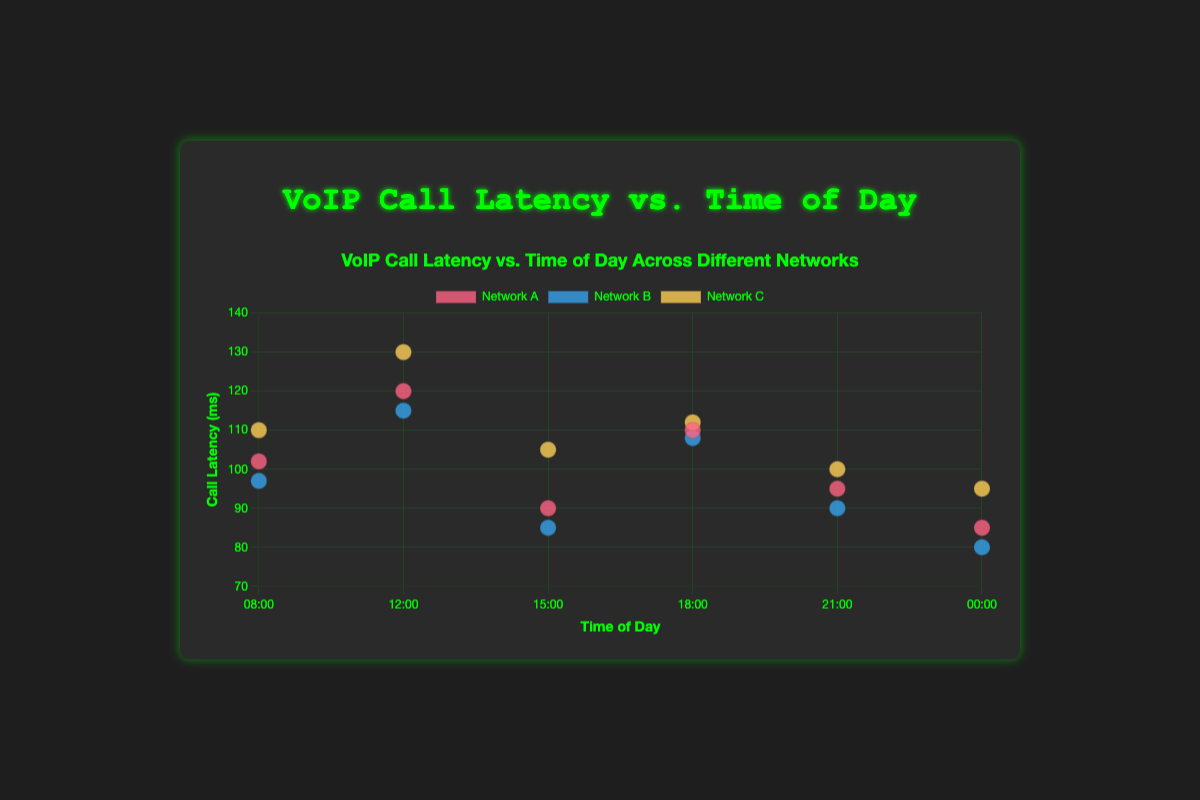What is the title of the scatter plot? The title is displayed at the top of the figure and reads "VoIP Call Latency vs. Time of Day Across Different Networks".
Answer: VoIP Call Latency vs. Time of Day Across Different Networks What are the labels on the x and y axes? The x-axis label reads "Time of Day" and the y-axis label reads "Call Latency (ms)". These labels are shown alongside their respective axes.
Answer: Time of Day, Call Latency (ms) For which network is call latency consistently lowest throughout the day? By observing the data points for each time slot, Network B typically has the lowest call latency values compared to Network A and Network C.
Answer: Network B At what time of day does Network C have its highest call latency? The highest call latency for Network C occurs at 12:00, where the latency value is 130 ms.
Answer: 12:00 Which network shows the most variation in call latency over the different times of the day? Network C exhibits the most variation in call latency, with values ranging from 95 ms to 130 ms throughout the day.
Answer: Network C What is the overall trend in call latency for Network A throughout the day? Network A's call latency is relatively high at 12:00 (120 ms), then drops at 15:00 (90 ms) and varies moderately in other time slots.
Answer: Variable with a peak at 12:00 How does the call latency at 18:00 compare across the three networks? At 18:00, Network A has a call latency of 110 ms, Network B has 108 ms, and Network C has 112 ms.
Answer: Network A: 110 ms, Network B: 108 ms, Network C: 112 ms Which network has the lowest call latency at midnight (00:00)? At 00:00, Network B has the lowest call latency of 80 ms, compared to 85 ms for Network A and 95 ms for Network C.
Answer: Network B What is the average call latency value for Network A throughout the day? Sum the call latency values for Network A (102, 120, 90, 110, 95, 85) to get 602, then divide by 6 (number of data points).
Answer: 100.33 ms Which time of day sees the highest call latency overall? At 12:00, the combined call latencies for all networks are the highest with values of 120 (Network A), 115 (Network B), and 130 (Network C).
Answer: 12:00 